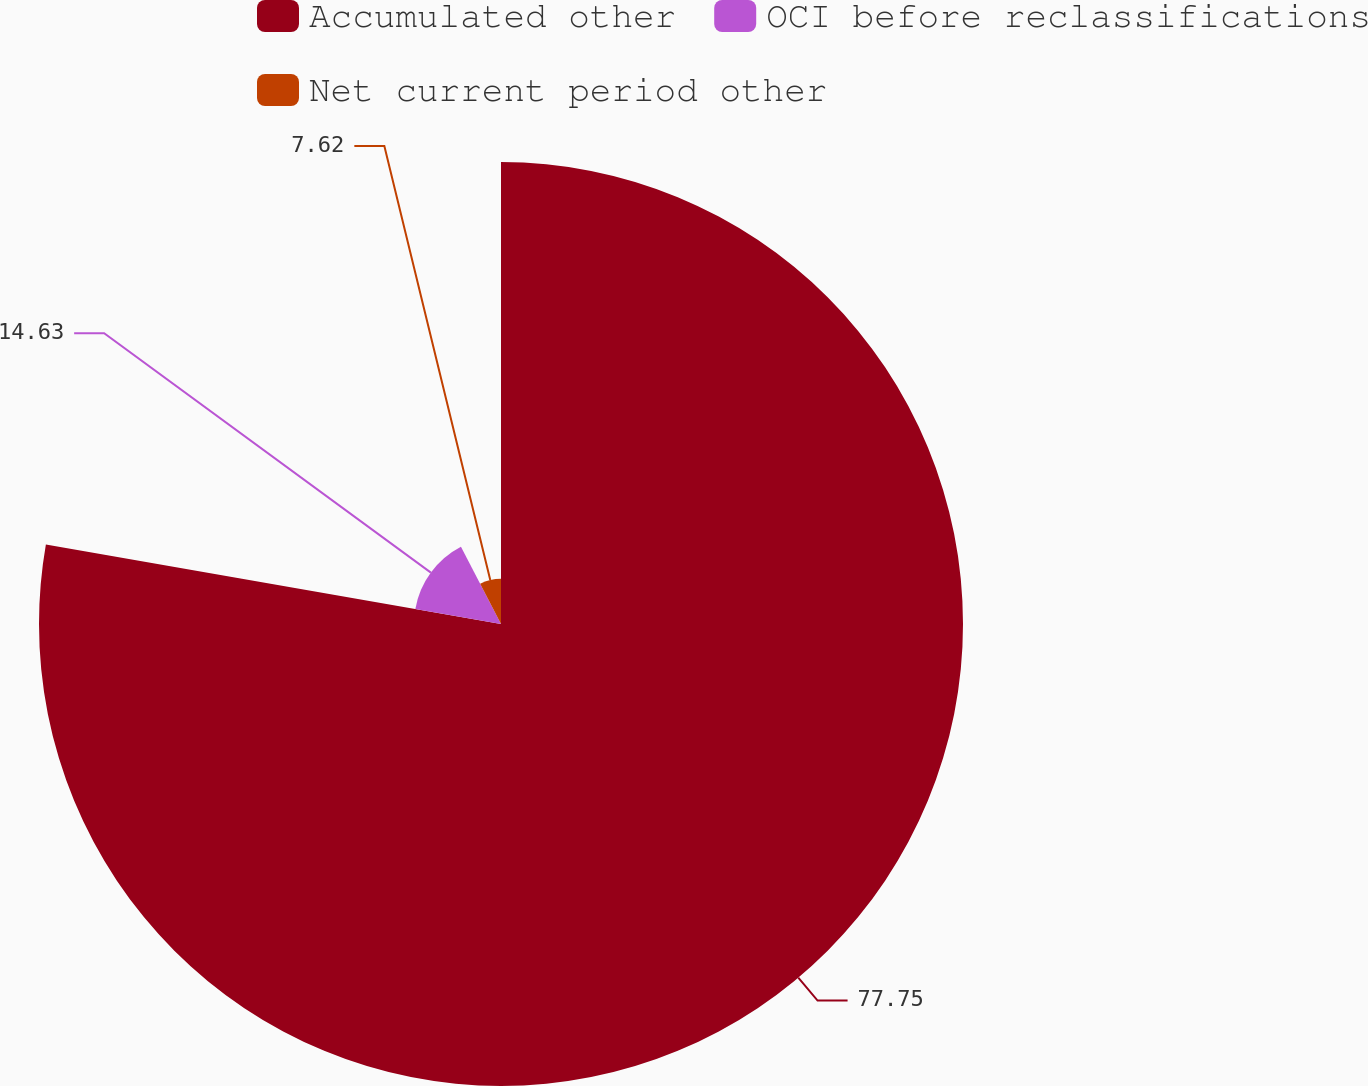Convert chart. <chart><loc_0><loc_0><loc_500><loc_500><pie_chart><fcel>Accumulated other<fcel>OCI before reclassifications<fcel>Net current period other<nl><fcel>77.75%<fcel>14.63%<fcel>7.62%<nl></chart> 